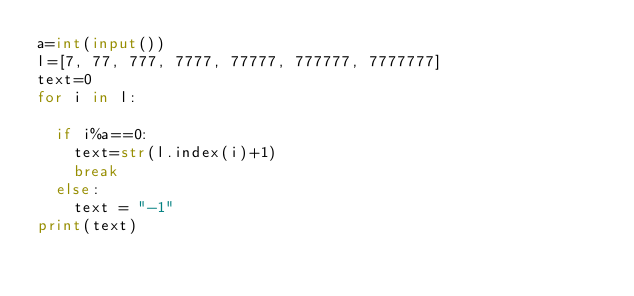<code> <loc_0><loc_0><loc_500><loc_500><_Python_>a=int(input())
l=[7, 77, 777, 7777, 77777, 777777, 7777777]
text=0
for i in l:
  
  if i%a==0:
    text=str(l.index(i)+1)
    break
  else:
    text = "-1"
print(text)</code> 